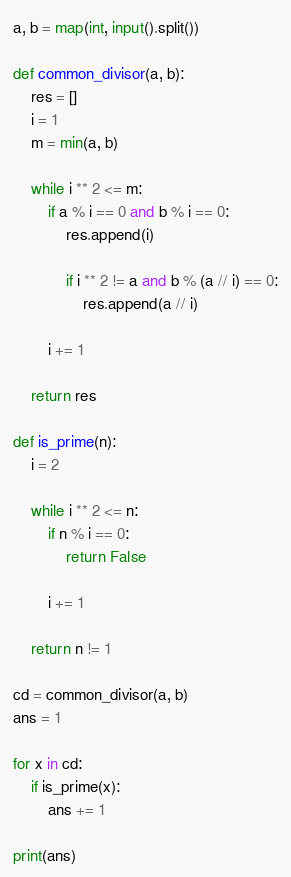Convert code to text. <code><loc_0><loc_0><loc_500><loc_500><_Python_>a, b = map(int, input().split())

def common_divisor(a, b):
    res = []
    i = 1
    m = min(a, b)
    
    while i ** 2 <= m:
        if a % i == 0 and b % i == 0:
            res.append(i)
            
            if i ** 2 != a and b % (a // i) == 0:
                res.append(a // i)
                
        i += 1
        
    return res

def is_prime(n):
    i = 2
    
    while i ** 2 <= n:
        if n % i == 0:
            return False
        
        i += 1
        
    return n != 1

cd = common_divisor(a, b)
ans = 1

for x in cd:
    if is_prime(x):
        ans += 1
        
print(ans)</code> 